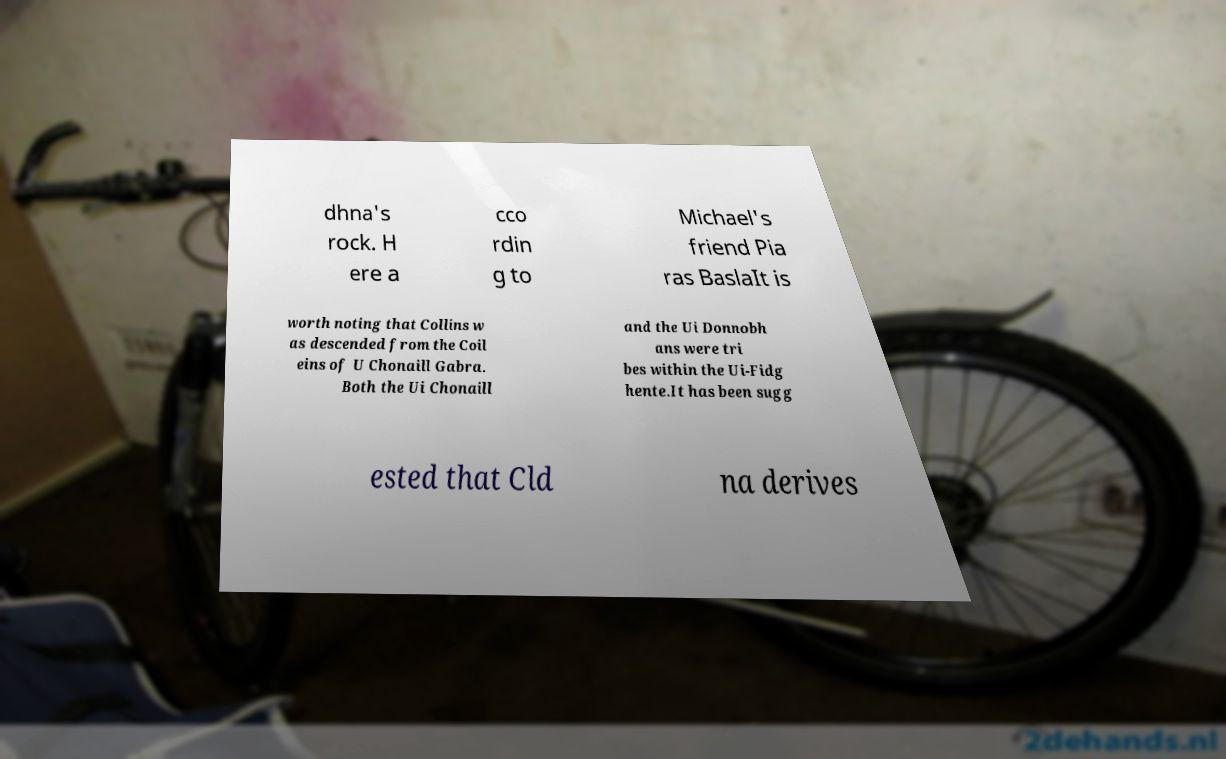Could you extract and type out the text from this image? dhna's rock. H ere a cco rdin g to Michael's friend Pia ras BaslaIt is worth noting that Collins w as descended from the Coil eins of U Chonaill Gabra. Both the Ui Chonaill and the Ui Donnobh ans were tri bes within the Ui-Fidg hente.It has been sugg ested that Cld na derives 